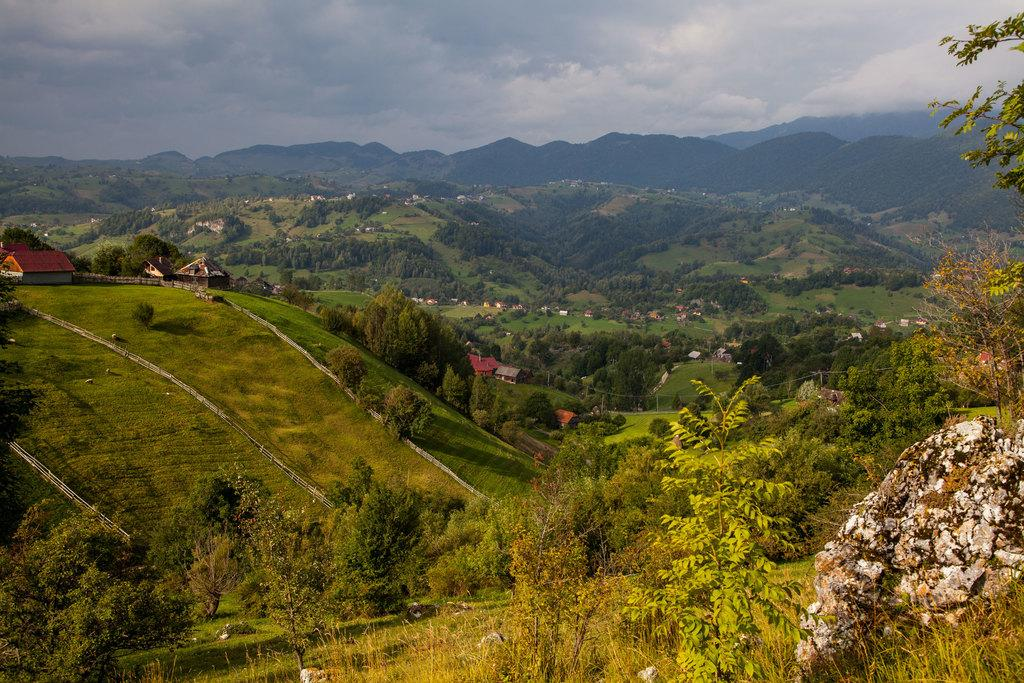What type of vegetation can be seen in the image? There are plants, grass, and trees in the image. What other natural elements are present in the image? There are rocks and stones in the image. Are there any man-made structures visible in the image? Yes, there are houses and wooden fences in the image. What is visible at the top of the image? The sky is visible at the top of the image. What can be seen in the sky? There are clouds in the sky. What type of terrain is visible in the image? There are mountains in the image. What type of wood is used to build the air in the image? There is no air visible in the image, and no wood is used to build it. How does the image show respect for the environment? The image itself does not show respect for the environment; it is a static representation of a scene. However, the presence of natural elements like plants, grass, trees, and mountains may inspire viewers to appreciate and respect the environment. 